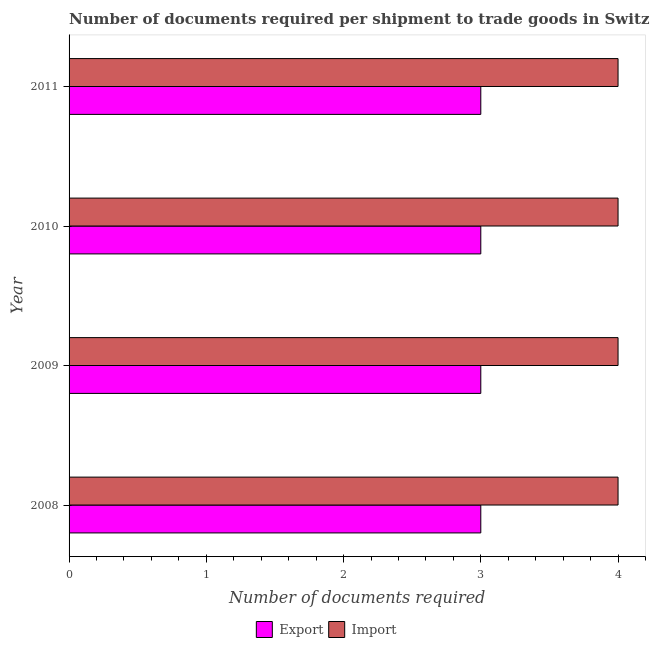How many groups of bars are there?
Your response must be concise. 4. How many bars are there on the 4th tick from the top?
Your answer should be compact. 2. What is the label of the 1st group of bars from the top?
Your answer should be compact. 2011. In how many cases, is the number of bars for a given year not equal to the number of legend labels?
Offer a terse response. 0. What is the number of documents required to export goods in 2011?
Keep it short and to the point. 3. Across all years, what is the maximum number of documents required to import goods?
Provide a short and direct response. 4. Across all years, what is the minimum number of documents required to export goods?
Keep it short and to the point. 3. In which year was the number of documents required to import goods maximum?
Offer a terse response. 2008. In which year was the number of documents required to import goods minimum?
Make the answer very short. 2008. What is the total number of documents required to export goods in the graph?
Give a very brief answer. 12. What is the difference between the number of documents required to export goods in 2009 and that in 2011?
Your response must be concise. 0. What is the difference between the number of documents required to import goods in 2010 and the number of documents required to export goods in 2011?
Make the answer very short. 1. What is the average number of documents required to import goods per year?
Provide a succinct answer. 4. In the year 2010, what is the difference between the number of documents required to export goods and number of documents required to import goods?
Provide a succinct answer. -1. Is the difference between the number of documents required to import goods in 2008 and 2010 greater than the difference between the number of documents required to export goods in 2008 and 2010?
Your answer should be very brief. No. What is the difference between the highest and the lowest number of documents required to export goods?
Make the answer very short. 0. In how many years, is the number of documents required to import goods greater than the average number of documents required to import goods taken over all years?
Provide a short and direct response. 0. What does the 2nd bar from the top in 2008 represents?
Give a very brief answer. Export. What does the 2nd bar from the bottom in 2011 represents?
Your answer should be very brief. Import. How many bars are there?
Keep it short and to the point. 8. Are all the bars in the graph horizontal?
Give a very brief answer. Yes. How many years are there in the graph?
Keep it short and to the point. 4. What is the difference between two consecutive major ticks on the X-axis?
Your response must be concise. 1. Does the graph contain grids?
Provide a short and direct response. No. Where does the legend appear in the graph?
Keep it short and to the point. Bottom center. How many legend labels are there?
Ensure brevity in your answer.  2. What is the title of the graph?
Provide a succinct answer. Number of documents required per shipment to trade goods in Switzerland. What is the label or title of the X-axis?
Your response must be concise. Number of documents required. What is the label or title of the Y-axis?
Offer a terse response. Year. What is the Number of documents required of Export in 2008?
Offer a terse response. 3. What is the Number of documents required of Import in 2008?
Make the answer very short. 4. What is the Number of documents required of Export in 2009?
Make the answer very short. 3. What is the Number of documents required of Import in 2009?
Provide a short and direct response. 4. What is the Number of documents required in Import in 2010?
Your answer should be very brief. 4. What is the Number of documents required of Export in 2011?
Provide a succinct answer. 3. What is the Number of documents required in Import in 2011?
Give a very brief answer. 4. Across all years, what is the minimum Number of documents required in Export?
Your answer should be compact. 3. Across all years, what is the minimum Number of documents required of Import?
Give a very brief answer. 4. What is the total Number of documents required of Export in the graph?
Offer a terse response. 12. What is the total Number of documents required of Import in the graph?
Ensure brevity in your answer.  16. What is the difference between the Number of documents required in Export in 2008 and that in 2009?
Your answer should be compact. 0. What is the difference between the Number of documents required of Import in 2008 and that in 2009?
Your response must be concise. 0. What is the difference between the Number of documents required in Export in 2008 and that in 2010?
Your response must be concise. 0. What is the difference between the Number of documents required of Export in 2009 and that in 2010?
Your answer should be compact. 0. What is the difference between the Number of documents required in Export in 2009 and that in 2011?
Offer a terse response. 0. What is the difference between the Number of documents required of Export in 2010 and that in 2011?
Provide a short and direct response. 0. What is the difference between the Number of documents required of Export in 2008 and the Number of documents required of Import in 2009?
Ensure brevity in your answer.  -1. What is the difference between the Number of documents required of Export in 2008 and the Number of documents required of Import in 2010?
Offer a very short reply. -1. What is the difference between the Number of documents required in Export in 2009 and the Number of documents required in Import in 2010?
Your response must be concise. -1. What is the difference between the Number of documents required in Export in 2009 and the Number of documents required in Import in 2011?
Ensure brevity in your answer.  -1. What is the average Number of documents required in Export per year?
Provide a succinct answer. 3. What is the average Number of documents required in Import per year?
Provide a succinct answer. 4. In the year 2011, what is the difference between the Number of documents required of Export and Number of documents required of Import?
Offer a terse response. -1. What is the ratio of the Number of documents required in Import in 2008 to that in 2009?
Offer a terse response. 1. What is the ratio of the Number of documents required of Export in 2008 to that in 2010?
Offer a terse response. 1. What is the ratio of the Number of documents required in Import in 2008 to that in 2010?
Give a very brief answer. 1. What is the ratio of the Number of documents required in Export in 2008 to that in 2011?
Offer a terse response. 1. What is the ratio of the Number of documents required in Import in 2008 to that in 2011?
Provide a succinct answer. 1. What is the ratio of the Number of documents required in Export in 2009 to that in 2010?
Give a very brief answer. 1. What is the ratio of the Number of documents required in Import in 2009 to that in 2011?
Ensure brevity in your answer.  1. What is the difference between the highest and the second highest Number of documents required in Export?
Provide a succinct answer. 0. What is the difference between the highest and the second highest Number of documents required of Import?
Your response must be concise. 0. What is the difference between the highest and the lowest Number of documents required in Import?
Offer a very short reply. 0. 